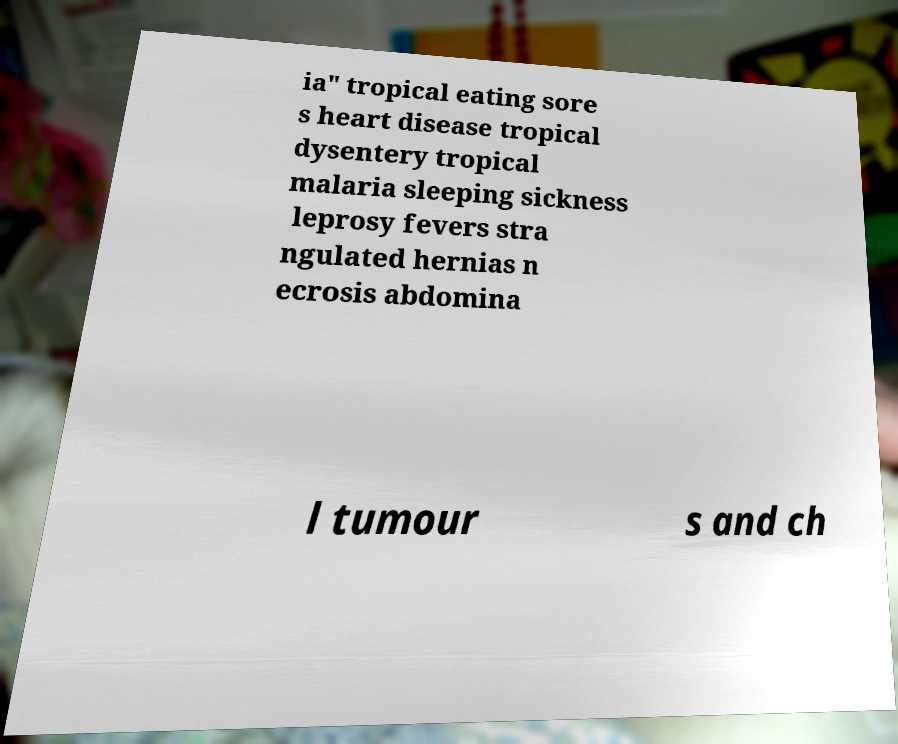There's text embedded in this image that I need extracted. Can you transcribe it verbatim? ia" tropical eating sore s heart disease tropical dysentery tropical malaria sleeping sickness leprosy fevers stra ngulated hernias n ecrosis abdomina l tumour s and ch 